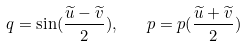<formula> <loc_0><loc_0><loc_500><loc_500>q = \sin ( \frac { \widetilde { u } - \widetilde { v } } { 2 } ) , \quad p = p ( \frac { \widetilde { u } + \widetilde { v } } { 2 } )</formula> 